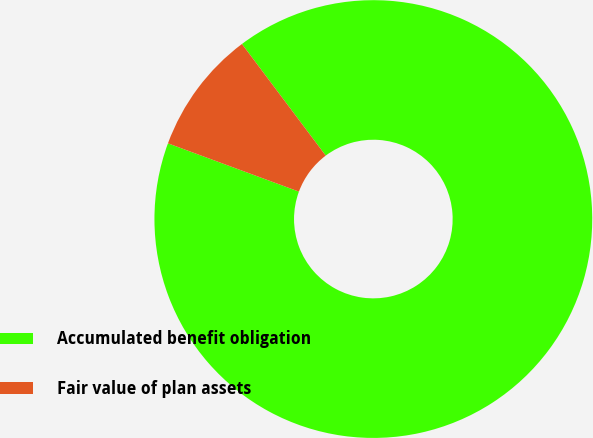Convert chart to OTSL. <chart><loc_0><loc_0><loc_500><loc_500><pie_chart><fcel>Accumulated benefit obligation<fcel>Fair value of plan assets<nl><fcel>90.87%<fcel>9.13%<nl></chart> 